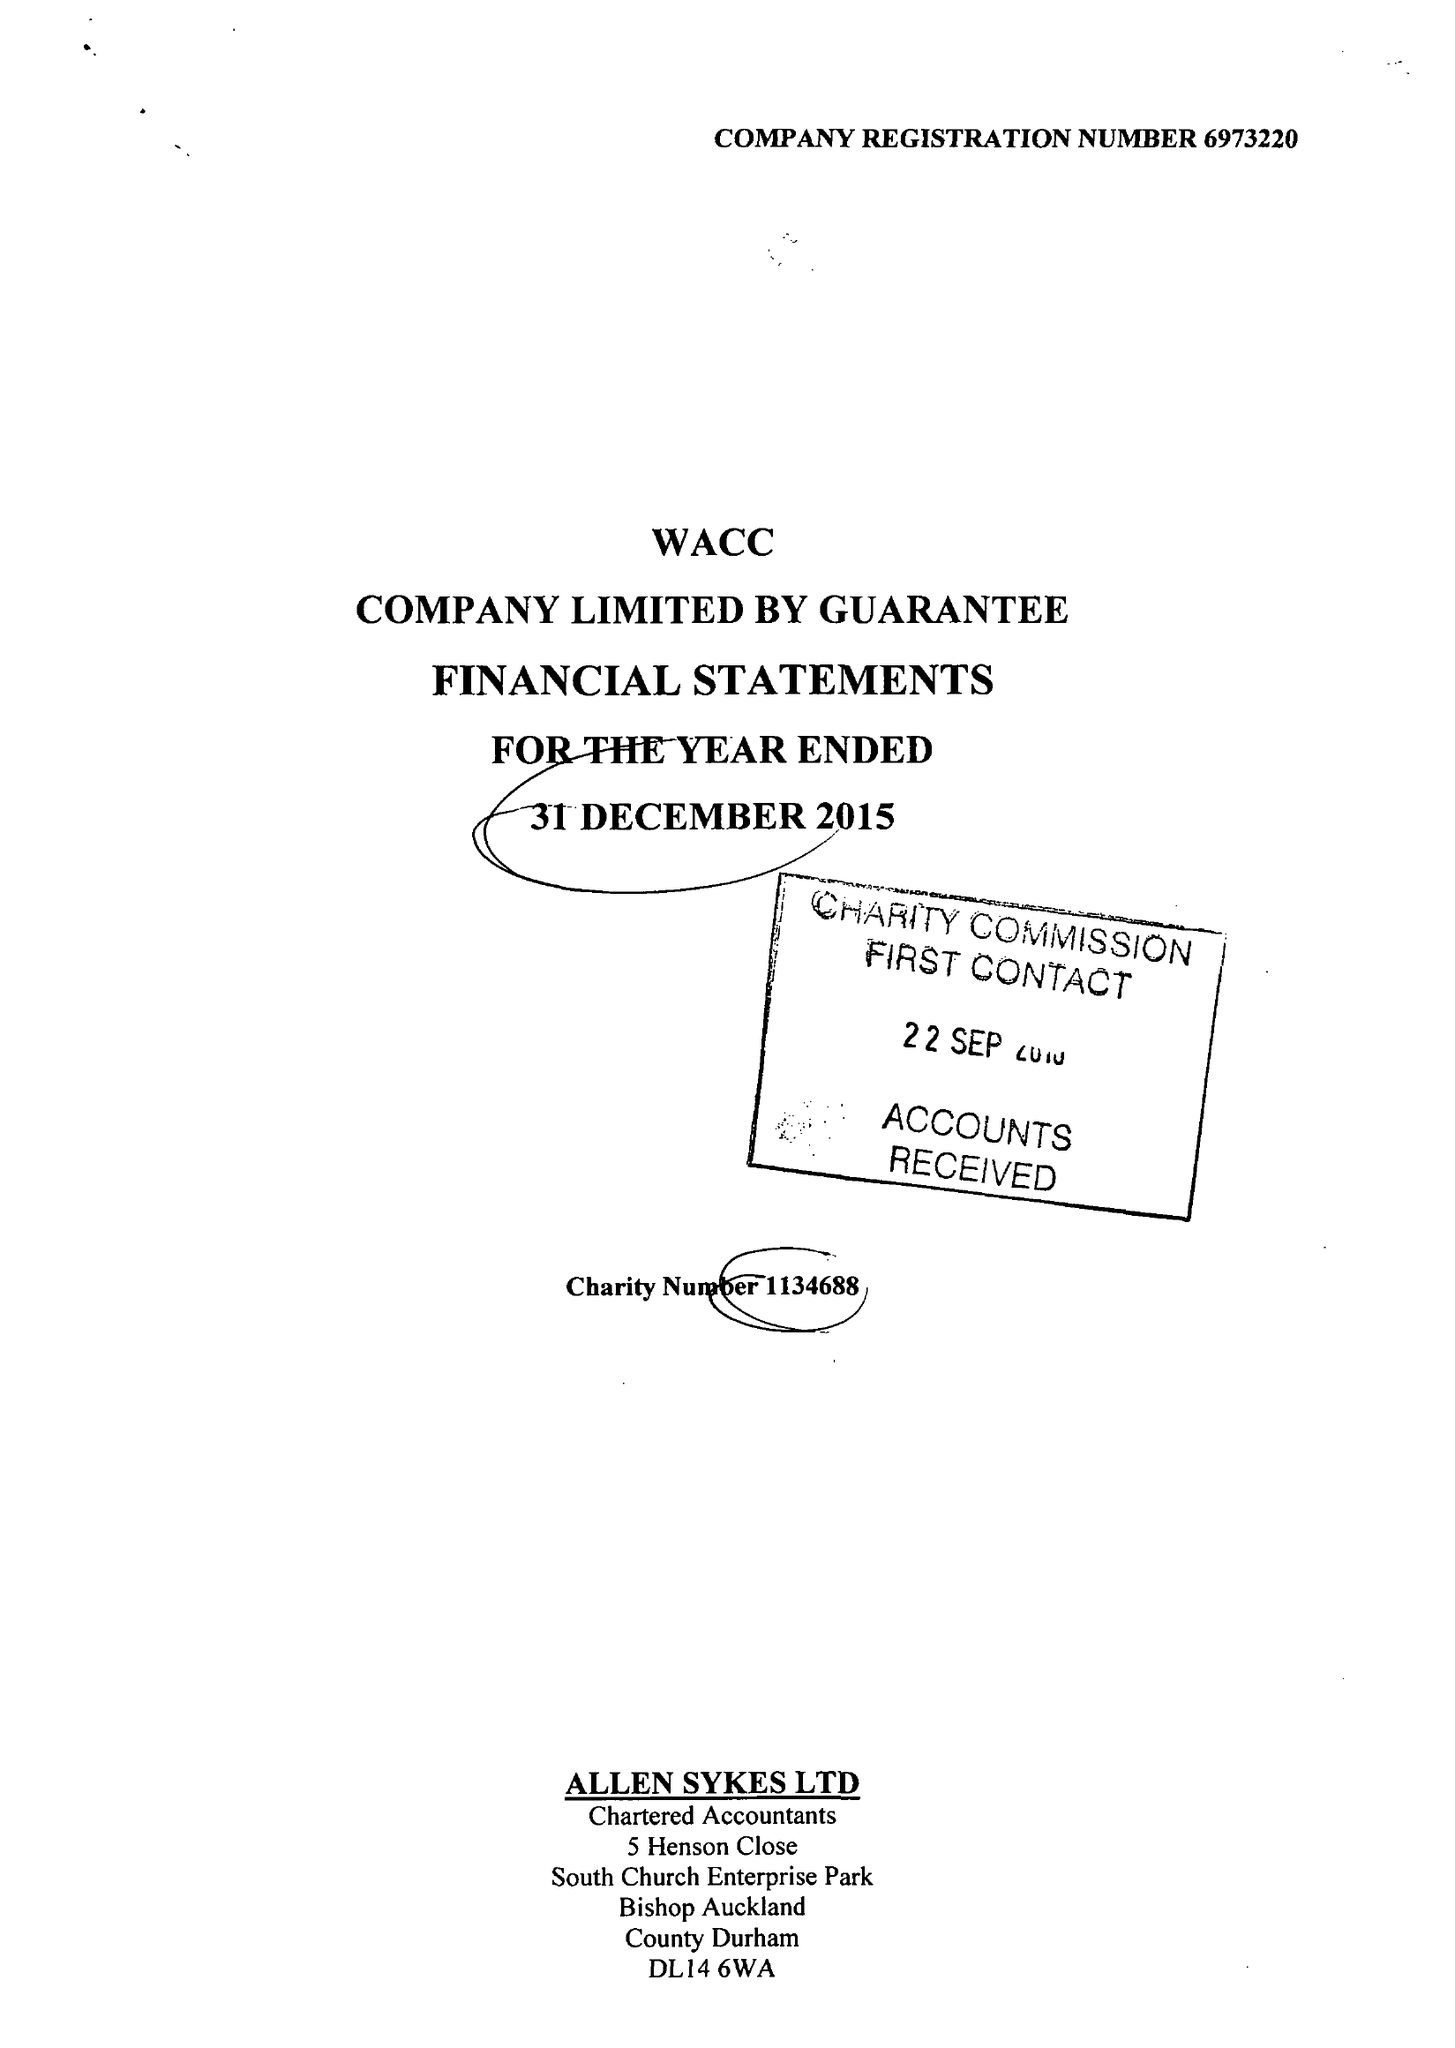What is the value for the address__post_town?
Answer the question using a single word or phrase. BISHOP AUCKLAND 